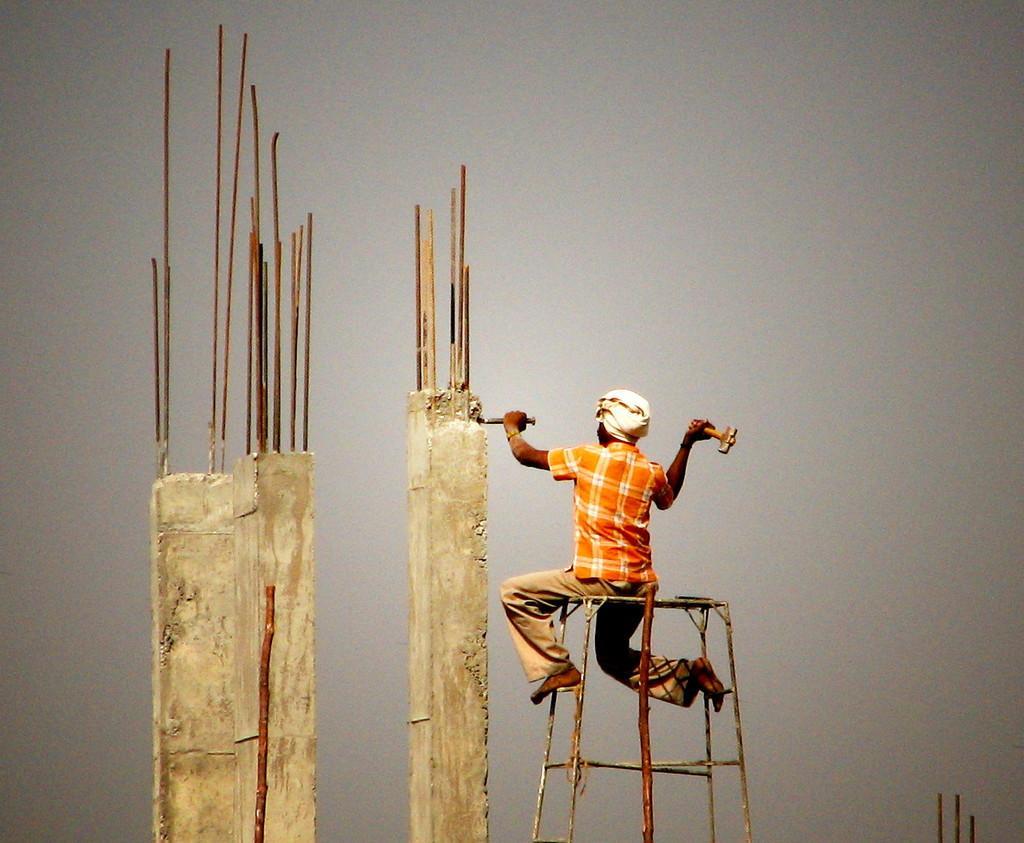Please provide a concise description of this image. In this image we can see a person sitting on the metal stool and holding the objects. We can also see two concrete pillars with the iron and the background of the image is in plain color. 